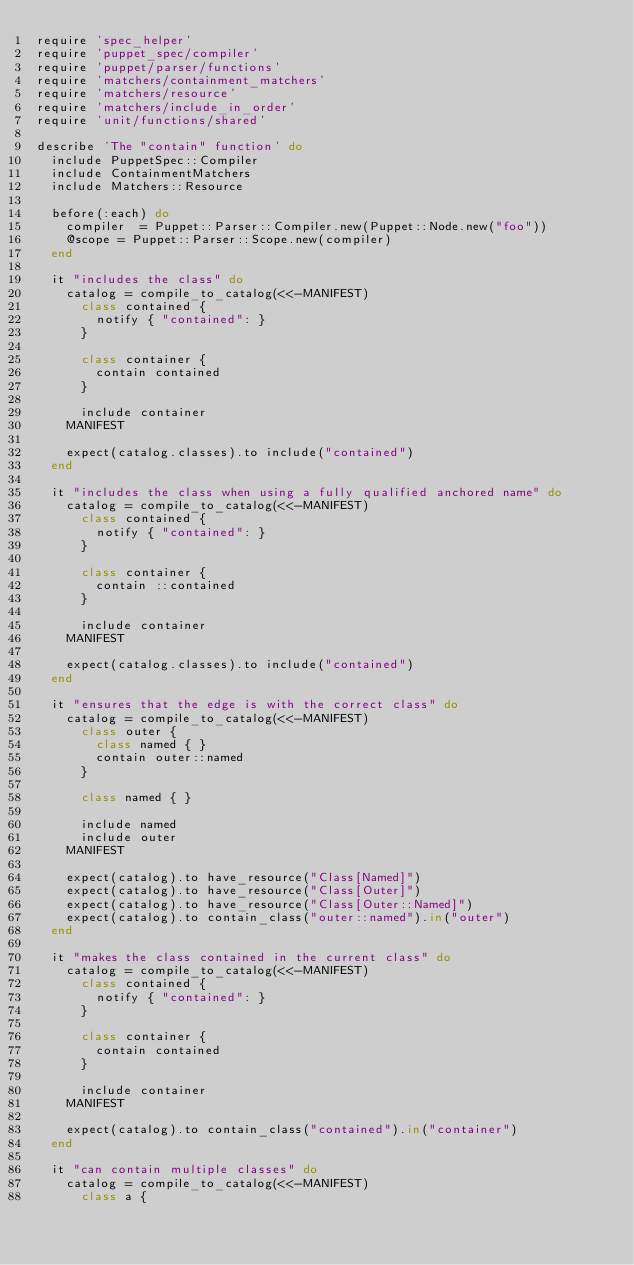<code> <loc_0><loc_0><loc_500><loc_500><_Ruby_>require 'spec_helper'
require 'puppet_spec/compiler'
require 'puppet/parser/functions'
require 'matchers/containment_matchers'
require 'matchers/resource'
require 'matchers/include_in_order'
require 'unit/functions/shared'

describe 'The "contain" function' do
  include PuppetSpec::Compiler
  include ContainmentMatchers
  include Matchers::Resource

  before(:each) do
    compiler  = Puppet::Parser::Compiler.new(Puppet::Node.new("foo"))
    @scope = Puppet::Parser::Scope.new(compiler)
  end

  it "includes the class" do
    catalog = compile_to_catalog(<<-MANIFEST)
      class contained {
        notify { "contained": }
      }

      class container {
        contain contained
      }

      include container
    MANIFEST

    expect(catalog.classes).to include("contained")
  end

  it "includes the class when using a fully qualified anchored name" do
    catalog = compile_to_catalog(<<-MANIFEST)
      class contained {
        notify { "contained": }
      }

      class container {
        contain ::contained
      }

      include container
    MANIFEST

    expect(catalog.classes).to include("contained")
  end

  it "ensures that the edge is with the correct class" do
    catalog = compile_to_catalog(<<-MANIFEST)
      class outer {
        class named { }
        contain outer::named
      }

      class named { }

      include named
      include outer
    MANIFEST

    expect(catalog).to have_resource("Class[Named]")
    expect(catalog).to have_resource("Class[Outer]")
    expect(catalog).to have_resource("Class[Outer::Named]")
    expect(catalog).to contain_class("outer::named").in("outer")
  end

  it "makes the class contained in the current class" do
    catalog = compile_to_catalog(<<-MANIFEST)
      class contained {
        notify { "contained": }
      }

      class container {
        contain contained
      }

      include container
    MANIFEST

    expect(catalog).to contain_class("contained").in("container")
  end

  it "can contain multiple classes" do
    catalog = compile_to_catalog(<<-MANIFEST)
      class a {</code> 